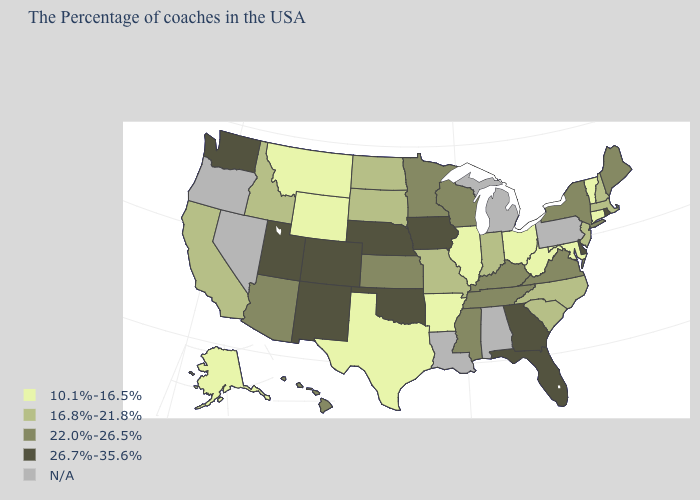What is the lowest value in states that border California?
Be succinct. 22.0%-26.5%. What is the value of Michigan?
Concise answer only. N/A. Name the states that have a value in the range 10.1%-16.5%?
Write a very short answer. Vermont, Connecticut, Maryland, West Virginia, Ohio, Illinois, Arkansas, Texas, Wyoming, Montana, Alaska. Is the legend a continuous bar?
Answer briefly. No. Does New Mexico have the highest value in the West?
Give a very brief answer. Yes. Name the states that have a value in the range 16.8%-21.8%?
Write a very short answer. Massachusetts, New Hampshire, New Jersey, North Carolina, South Carolina, Indiana, Missouri, South Dakota, North Dakota, Idaho, California. Name the states that have a value in the range N/A?
Keep it brief. Pennsylvania, Michigan, Alabama, Louisiana, Nevada, Oregon. What is the value of Nebraska?
Quick response, please. 26.7%-35.6%. Name the states that have a value in the range 16.8%-21.8%?
Keep it brief. Massachusetts, New Hampshire, New Jersey, North Carolina, South Carolina, Indiana, Missouri, South Dakota, North Dakota, Idaho, California. Name the states that have a value in the range N/A?
Give a very brief answer. Pennsylvania, Michigan, Alabama, Louisiana, Nevada, Oregon. Does Indiana have the lowest value in the USA?
Concise answer only. No. Which states have the lowest value in the USA?
Quick response, please. Vermont, Connecticut, Maryland, West Virginia, Ohio, Illinois, Arkansas, Texas, Wyoming, Montana, Alaska. What is the value of Nevada?
Be succinct. N/A. What is the value of Mississippi?
Write a very short answer. 22.0%-26.5%. 